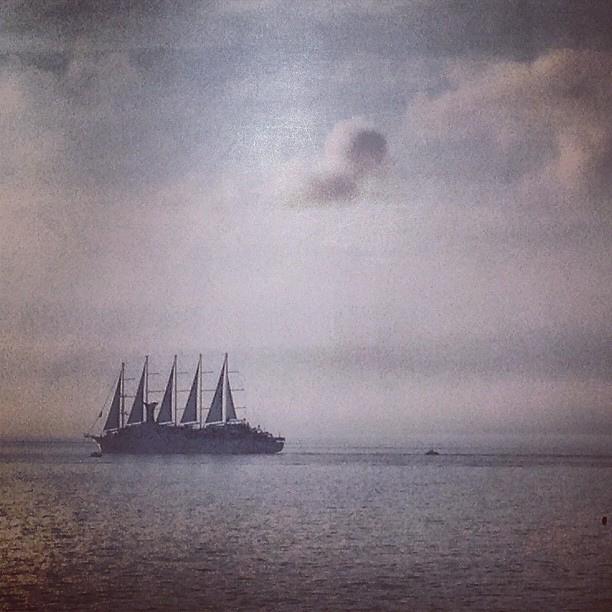Is the ship letting out smoke?
Short answer required. No. Is the boat on water or grass?
Answer briefly. Water. Where was it taken?
Quick response, please. Ocean. What color is the boat at the forefront of the picture?
Give a very brief answer. White. What is in the water?
Keep it brief. Ship. How many sails does the ship have?
Write a very short answer. 5. How is the ocean?
Short answer required. Calm. What caused the wave to be so uneven?
Quick response, please. Boat. 